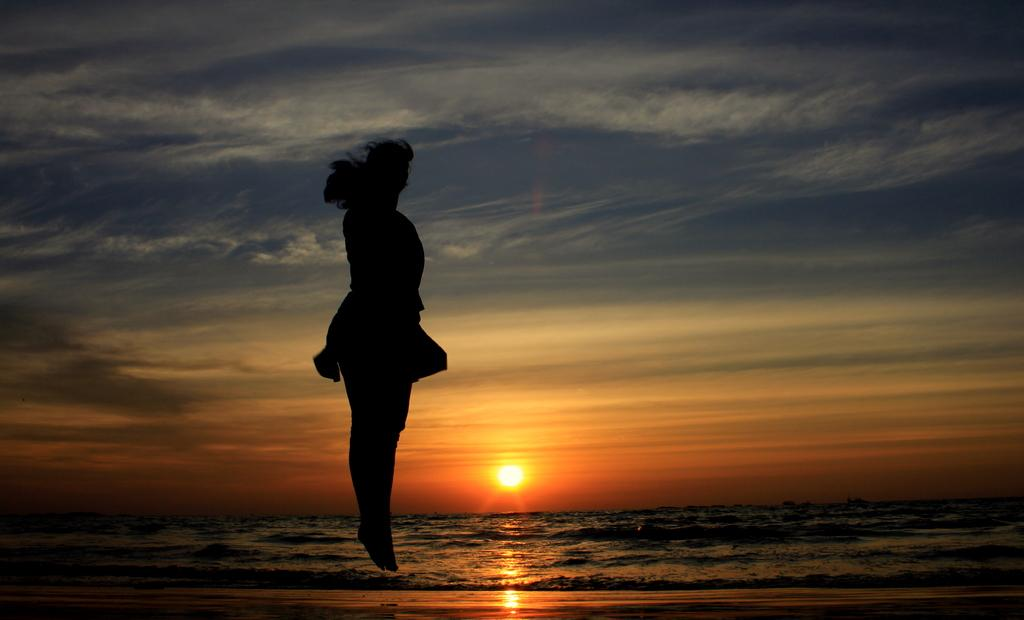What can be seen in the image that indicates a person's presence? There is a shadow of a person in the image. What action is the person performing in the image? The person appears to be jumping in the air. What type of surface is visible in the image? The ground is visible in the image. What natural element is present in the image? There is water visible in the image. What part of the sky is visible in the image? The sky is visible in the image. What celestial body can be seen in the sky? The sun is visible in the image. What type of art can be seen hanging on the wall in the image? There is no art or wall present in the image; it features a shadow of a person jumping in the air. What type of church is visible in the background of the image? There is no church present in the image; it features a shadow of a person jumping in the air with the sky, sun, ground, and water visible. 